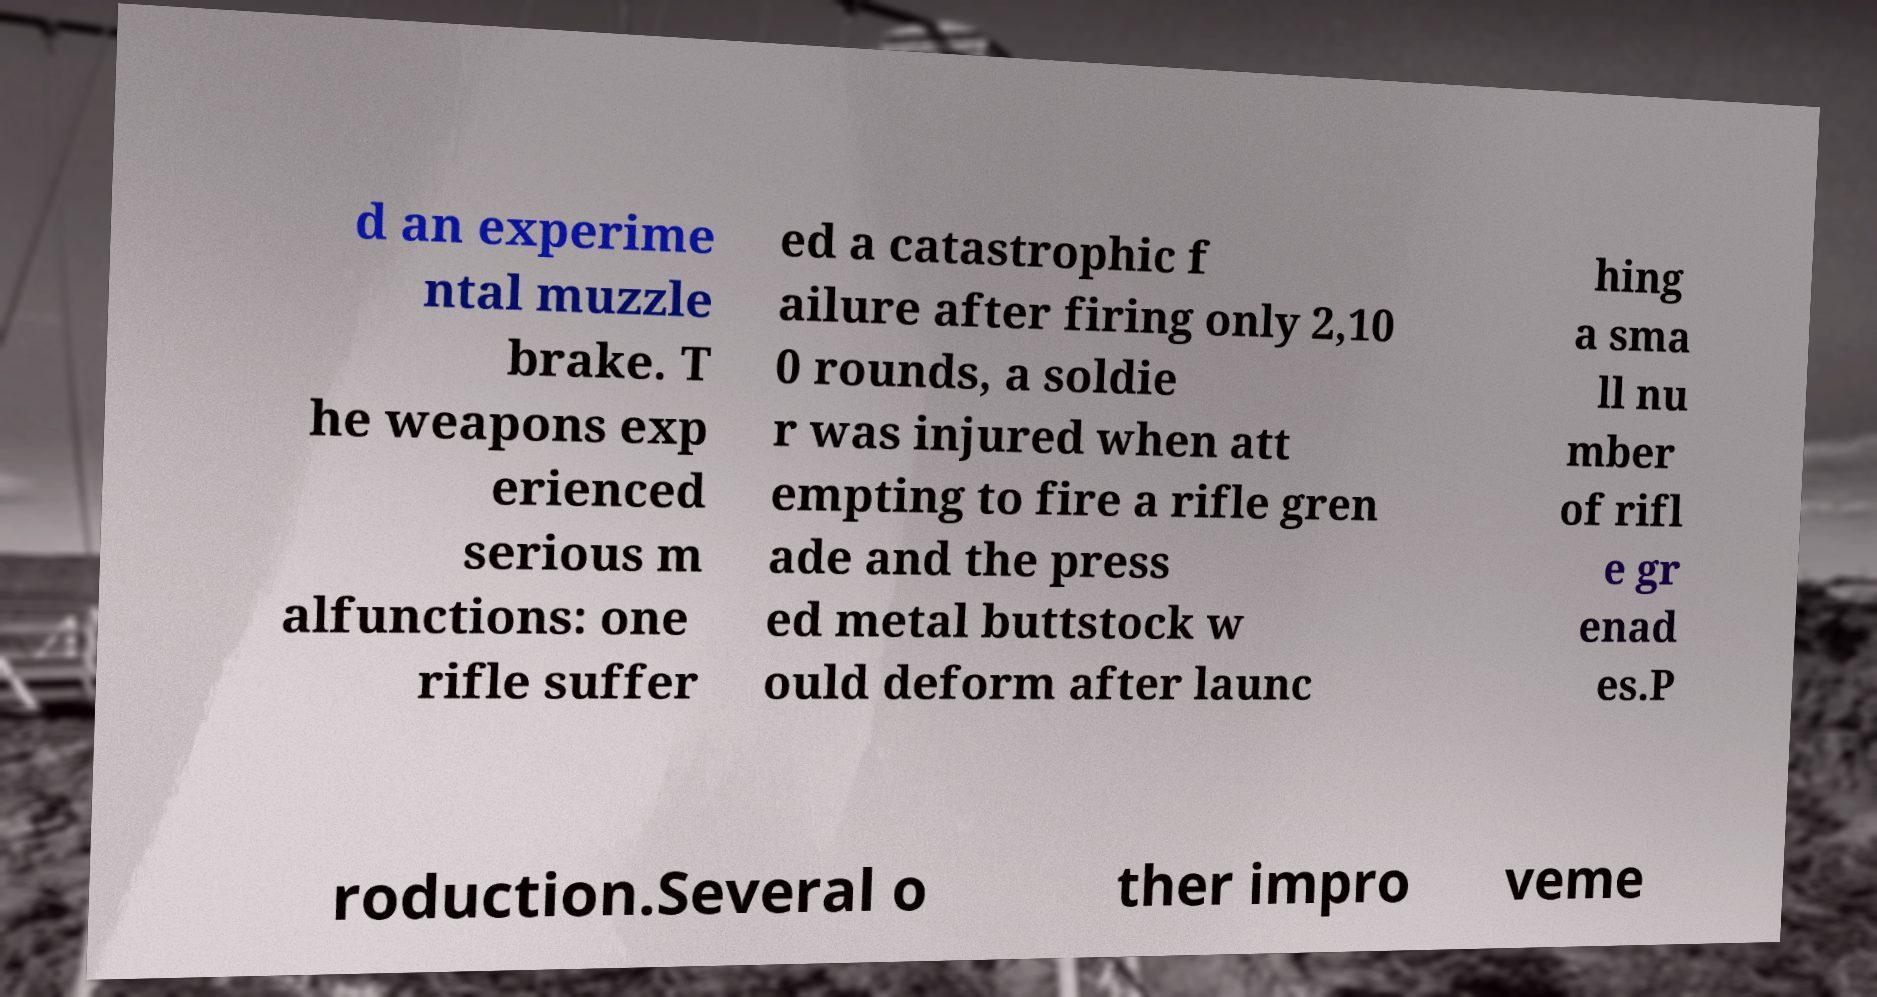Could you assist in decoding the text presented in this image and type it out clearly? d an experime ntal muzzle brake. T he weapons exp erienced serious m alfunctions: one rifle suffer ed a catastrophic f ailure after firing only 2,10 0 rounds, a soldie r was injured when att empting to fire a rifle gren ade and the press ed metal buttstock w ould deform after launc hing a sma ll nu mber of rifl e gr enad es.P roduction.Several o ther impro veme 